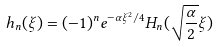<formula> <loc_0><loc_0><loc_500><loc_500>h _ { n } ( \xi ) = ( - 1 ) ^ { n } e ^ { - \alpha \xi ^ { 2 } / 4 } H _ { n } ( \sqrt { \frac { \alpha } { 2 } } \xi )</formula> 